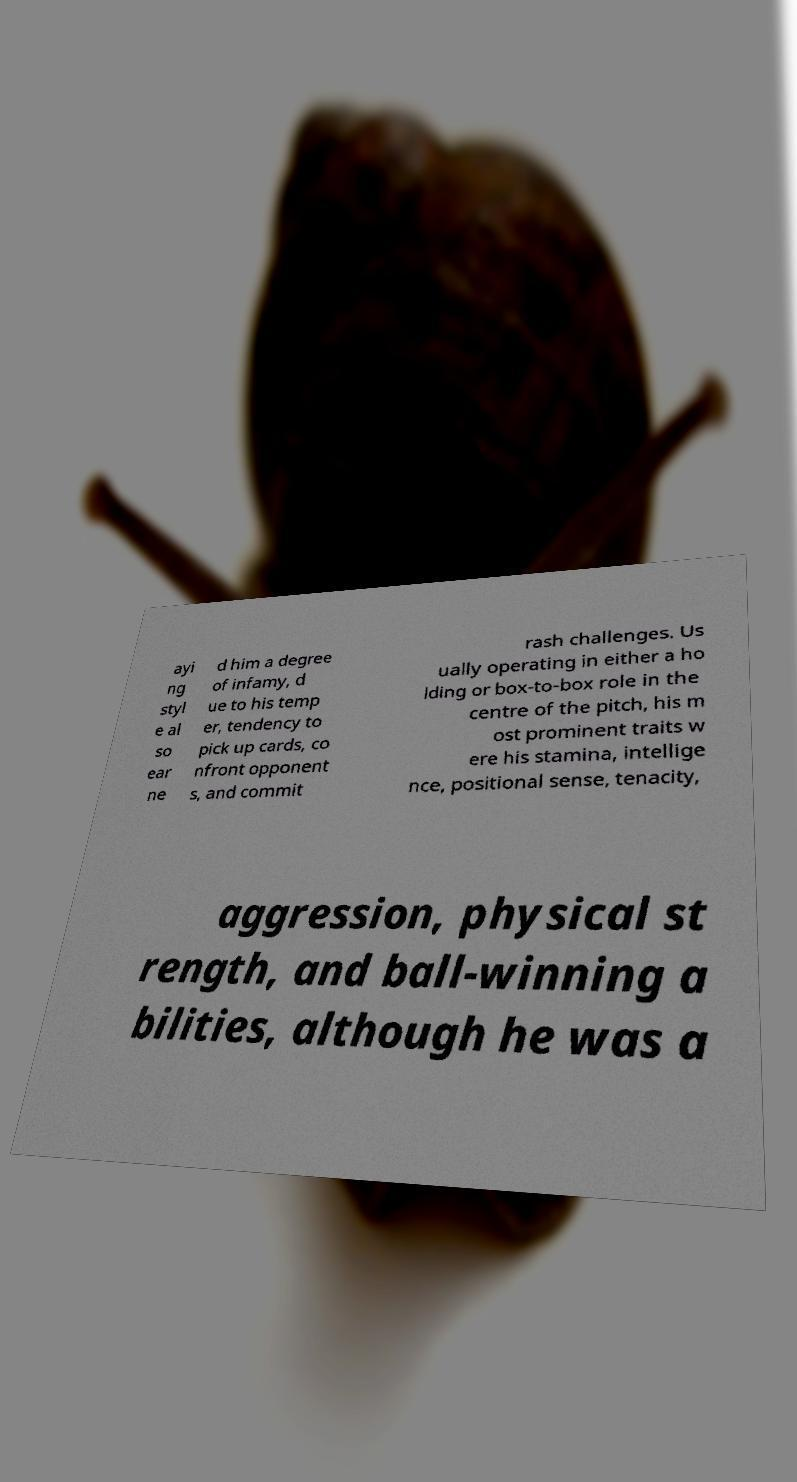For documentation purposes, I need the text within this image transcribed. Could you provide that? ayi ng styl e al so ear ne d him a degree of infamy, d ue to his temp er, tendency to pick up cards, co nfront opponent s, and commit rash challenges. Us ually operating in either a ho lding or box-to-box role in the centre of the pitch, his m ost prominent traits w ere his stamina, intellige nce, positional sense, tenacity, aggression, physical st rength, and ball-winning a bilities, although he was a 